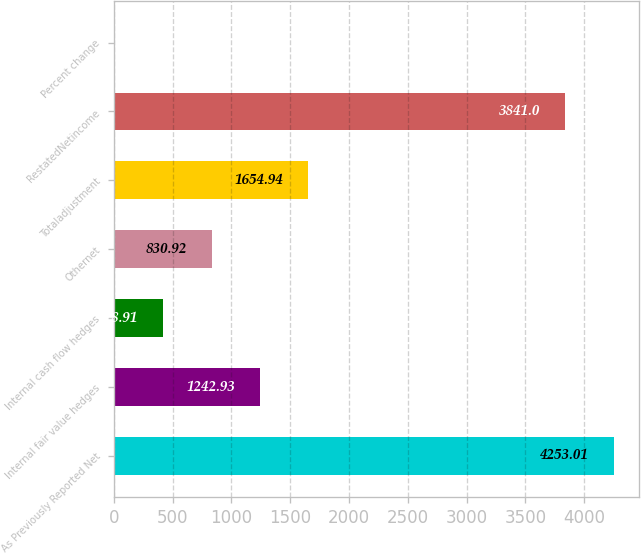Convert chart to OTSL. <chart><loc_0><loc_0><loc_500><loc_500><bar_chart><fcel>As Previously Reported Net<fcel>Internal fair value hedges<fcel>Internal cash flow hedges<fcel>Othernet<fcel>Totaladjustment<fcel>RestatedNetincome<fcel>Percent change<nl><fcel>4253.01<fcel>1242.93<fcel>418.91<fcel>830.92<fcel>1654.94<fcel>3841<fcel>6.9<nl></chart> 